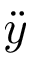<formula> <loc_0><loc_0><loc_500><loc_500>\ddot { y }</formula> 